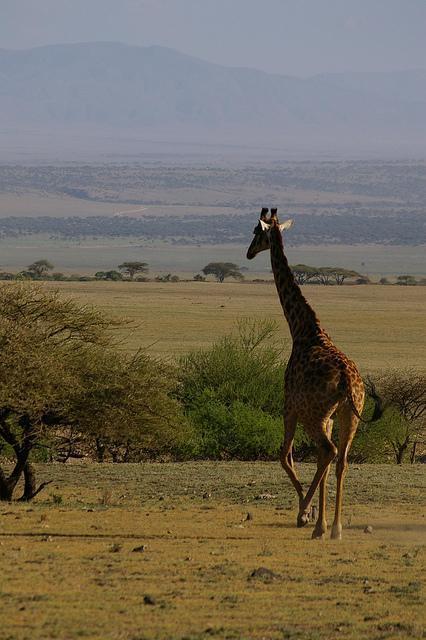How many giraffes are in the photo?
Give a very brief answer. 1. How many bus on the road?
Give a very brief answer. 0. 